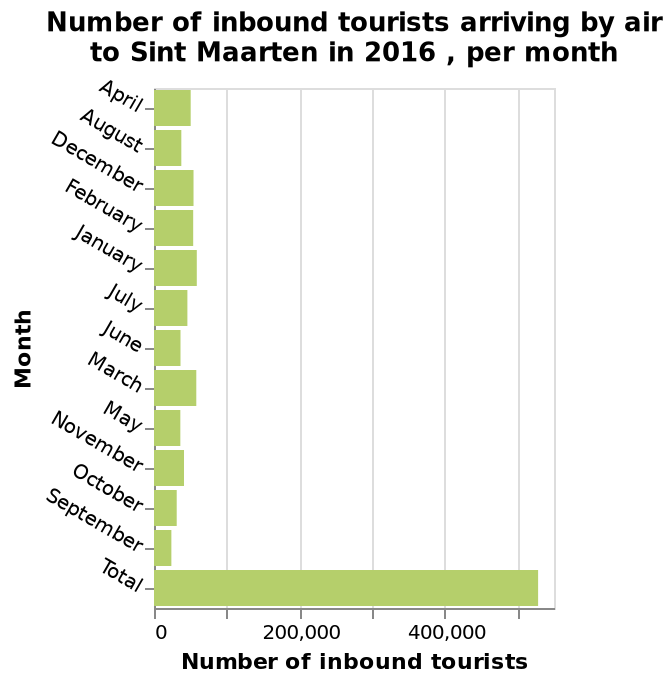<image>
When is the highest period for foreign visitors to visit Sint Maarten?  The highest period for foreign visitors to visit Sint Maarten is in March. When is the lowest period for foreign tourists to visit Sint Maarten? The lowest period for foreign tourists to visit Sint Maarten is in September. What is the name of the bar plot and what does it depict?  The bar plot is named "Number of inbound tourists arriving by air to Sint Maarten in 2016, per month," and it shows the monthly count of tourists arriving by air in Sint Maarten in the year 2016. What is the time period covered by this bar plot? The bar plot covers the year 2016. 